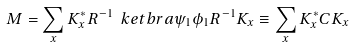Convert formula to latex. <formula><loc_0><loc_0><loc_500><loc_500>M = \sum _ { x } K _ { x } ^ { * } R ^ { - 1 } \ k e t b r a { \psi _ { 1 } } { \phi _ { 1 } } R ^ { - 1 } K _ { x } \equiv \sum _ { x } K _ { x } ^ { * } C K _ { x } \,</formula> 